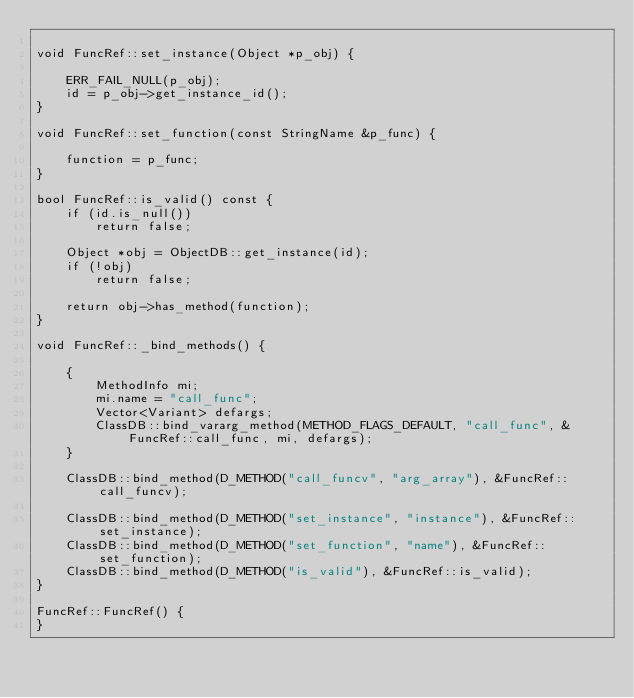<code> <loc_0><loc_0><loc_500><loc_500><_C++_>
void FuncRef::set_instance(Object *p_obj) {

	ERR_FAIL_NULL(p_obj);
	id = p_obj->get_instance_id();
}

void FuncRef::set_function(const StringName &p_func) {

	function = p_func;
}

bool FuncRef::is_valid() const {
	if (id.is_null())
		return false;

	Object *obj = ObjectDB::get_instance(id);
	if (!obj)
		return false;

	return obj->has_method(function);
}

void FuncRef::_bind_methods() {

	{
		MethodInfo mi;
		mi.name = "call_func";
		Vector<Variant> defargs;
		ClassDB::bind_vararg_method(METHOD_FLAGS_DEFAULT, "call_func", &FuncRef::call_func, mi, defargs);
	}

	ClassDB::bind_method(D_METHOD("call_funcv", "arg_array"), &FuncRef::call_funcv);

	ClassDB::bind_method(D_METHOD("set_instance", "instance"), &FuncRef::set_instance);
	ClassDB::bind_method(D_METHOD("set_function", "name"), &FuncRef::set_function);
	ClassDB::bind_method(D_METHOD("is_valid"), &FuncRef::is_valid);
}

FuncRef::FuncRef() {
}
</code> 